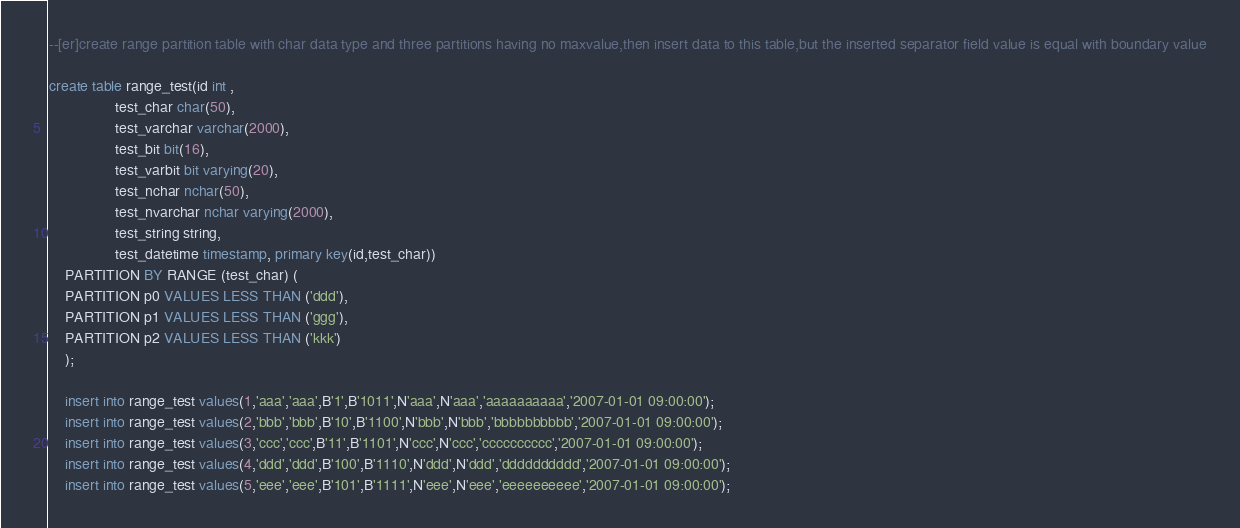Convert code to text. <code><loc_0><loc_0><loc_500><loc_500><_SQL_>--[er]create range partition table with char data type and three partitions having no maxvalue,then insert data to this table,but the inserted separator field value is equal with boundary value

create table range_test(id int ,
				test_char char(50),
				test_varchar varchar(2000),
				test_bit bit(16),
				test_varbit bit varying(20),
				test_nchar nchar(50),
				test_nvarchar nchar varying(2000),
				test_string string,
				test_datetime timestamp, primary key(id,test_char))
	PARTITION BY RANGE (test_char) (
	PARTITION p0 VALUES LESS THAN ('ddd'),
	PARTITION p1 VALUES LESS THAN ('ggg'),
	PARTITION p2 VALUES LESS THAN ('kkk')
	);

	insert into range_test values(1,'aaa','aaa',B'1',B'1011',N'aaa',N'aaa','aaaaaaaaaa','2007-01-01 09:00:00');
	insert into range_test values(2,'bbb','bbb',B'10',B'1100',N'bbb',N'bbb','bbbbbbbbbb','2007-01-01 09:00:00');
	insert into range_test values(3,'ccc','ccc',B'11',B'1101',N'ccc',N'ccc','cccccccccc','2007-01-01 09:00:00');
	insert into range_test values(4,'ddd','ddd',B'100',B'1110',N'ddd',N'ddd','dddddddddd','2007-01-01 09:00:00');
	insert into range_test values(5,'eee','eee',B'101',B'1111',N'eee',N'eee','eeeeeeeeee','2007-01-01 09:00:00');</code> 